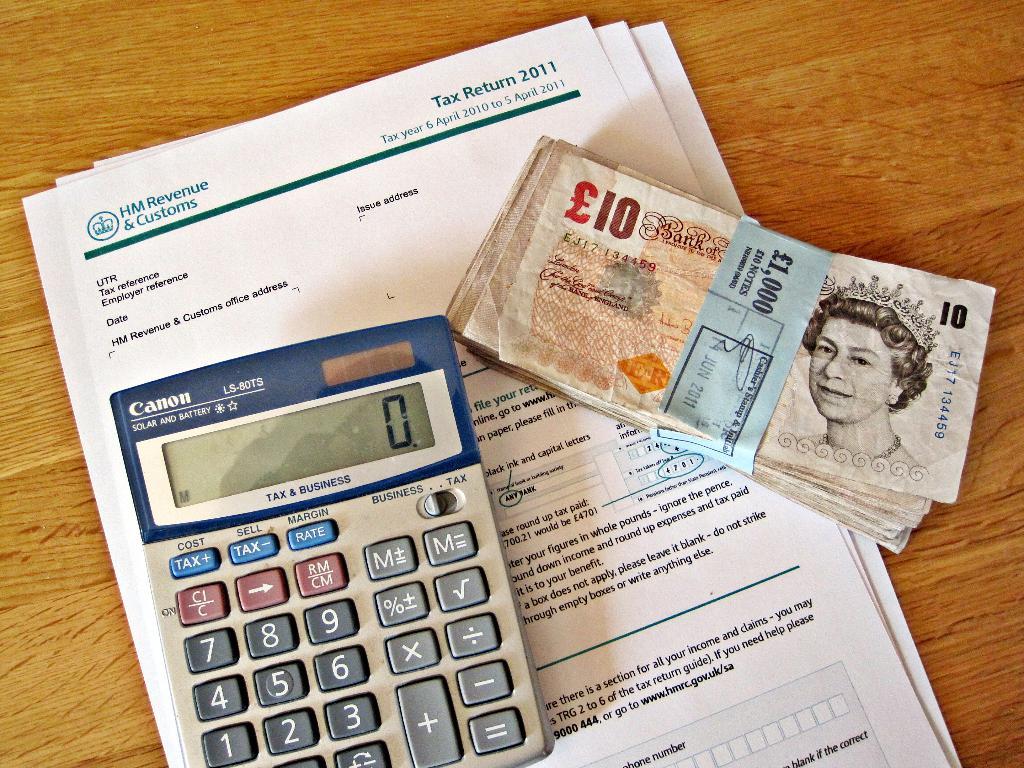What total is on the calculator?
Offer a terse response. 0. What year is this tax return from?
Your answer should be compact. 2011. 